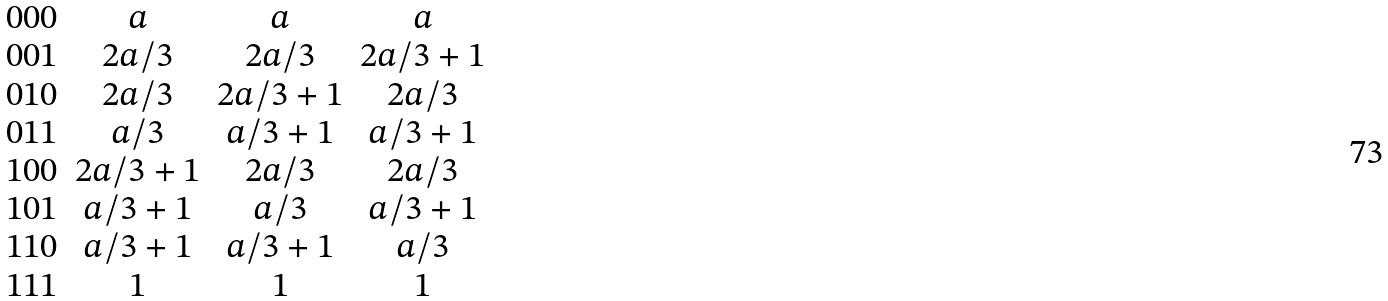Convert formula to latex. <formula><loc_0><loc_0><loc_500><loc_500>\begin{array} { c c c c } 0 0 0 & a & a & a \\ 0 0 1 & 2 a / 3 & 2 a / 3 & 2 a / 3 + 1 \\ 0 1 0 & 2 a / 3 & 2 a / 3 + 1 & 2 a / 3 \\ 0 1 1 & a / 3 & a / 3 + 1 & a / 3 + 1 \\ 1 0 0 & 2 a / 3 + 1 & 2 a / 3 & 2 a / 3 \\ 1 0 1 & a / 3 + 1 & a / 3 & a / 3 + 1 \\ 1 1 0 & a / 3 + 1 & a / 3 + 1 & a / 3 \\ 1 1 1 & 1 & 1 & 1 \end{array}</formula> 